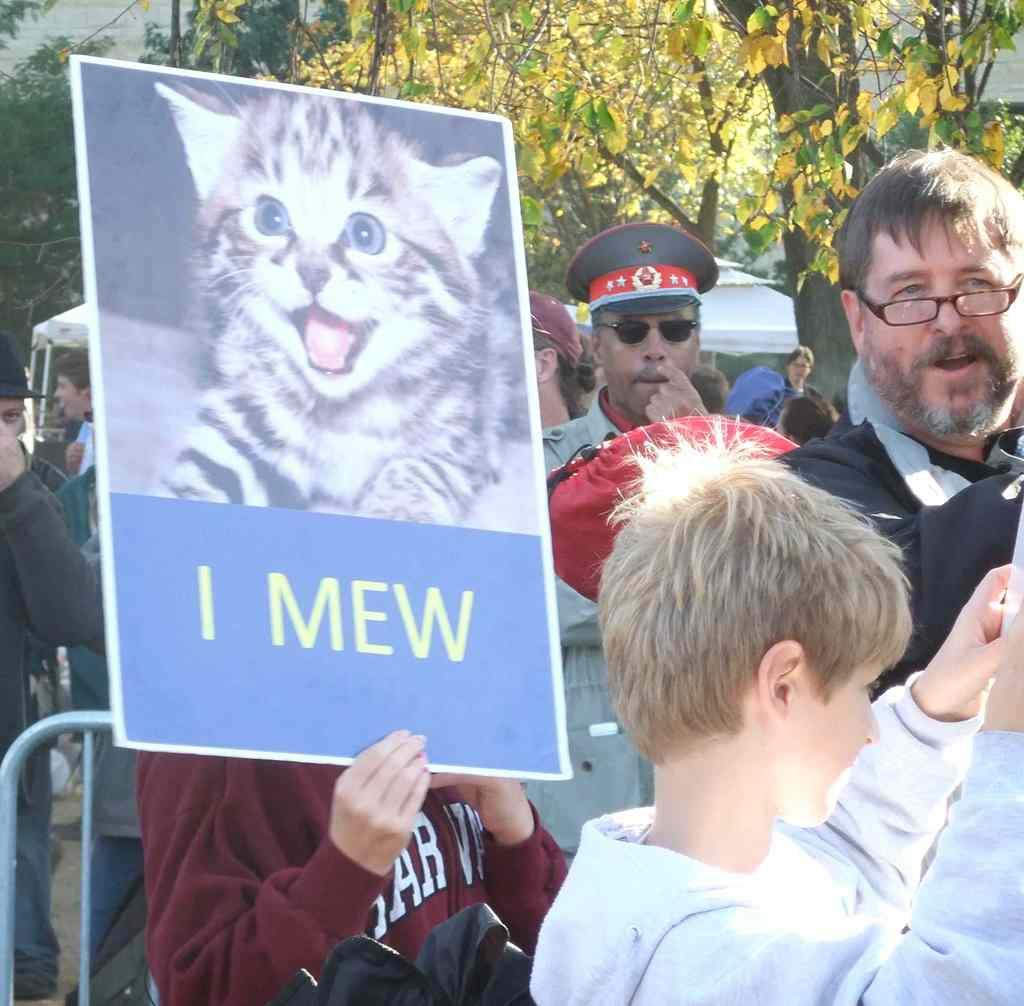How many people are in the image? There are people in the image, but the exact number is not specified. What is one person holding in the image? One person is holding a poster in the image. What object can be seen in the image that resembles a long, thin pole? There is a rod in the image. What type of personal item is visible in the image? There is a bag in the image. What can be seen in the background of the image? There are trees and a tent in the background of the image. What type of sound can be heard coming from the mice in the image? There are no mice present in the image, so it is not possible to determine what, if any, sounds they might make. What type of lettuce is being used to decorate the tent in the image? There is no lettuce present in the image, and the tent is not being decorated. 